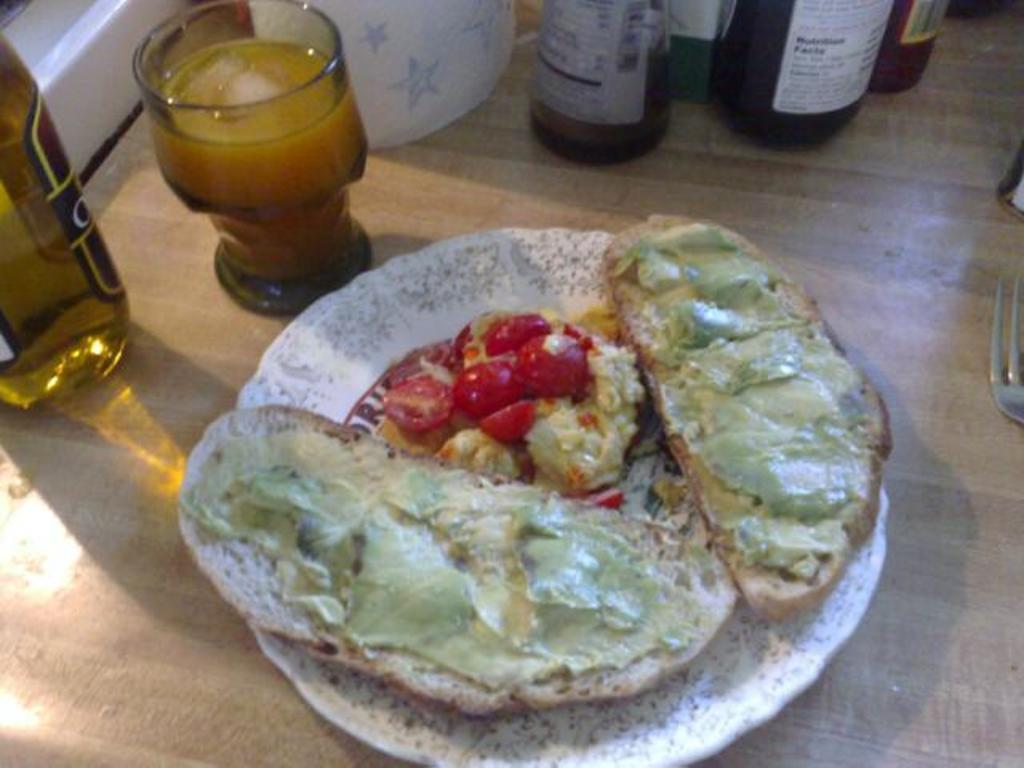Could you give a brief overview of what you see in this image? This is the picture of a meat and food in the plate , a glass , bottle , fork in the table. 